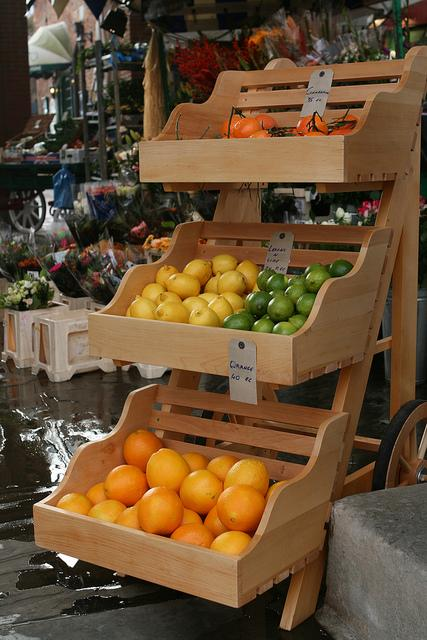The fruits in the raised wooden baskets seen here are all what? Please explain your reasoning. citrus. The oranges, lemons and limes are all citrus fruits. 